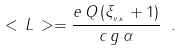<formula> <loc_0><loc_0><loc_500><loc_500>< \, L \, > = \frac { e \, Q \, ( \xi _ { _ { \nu , \kappa } } + 1 ) } { c \, g \, \alpha } \ .</formula> 